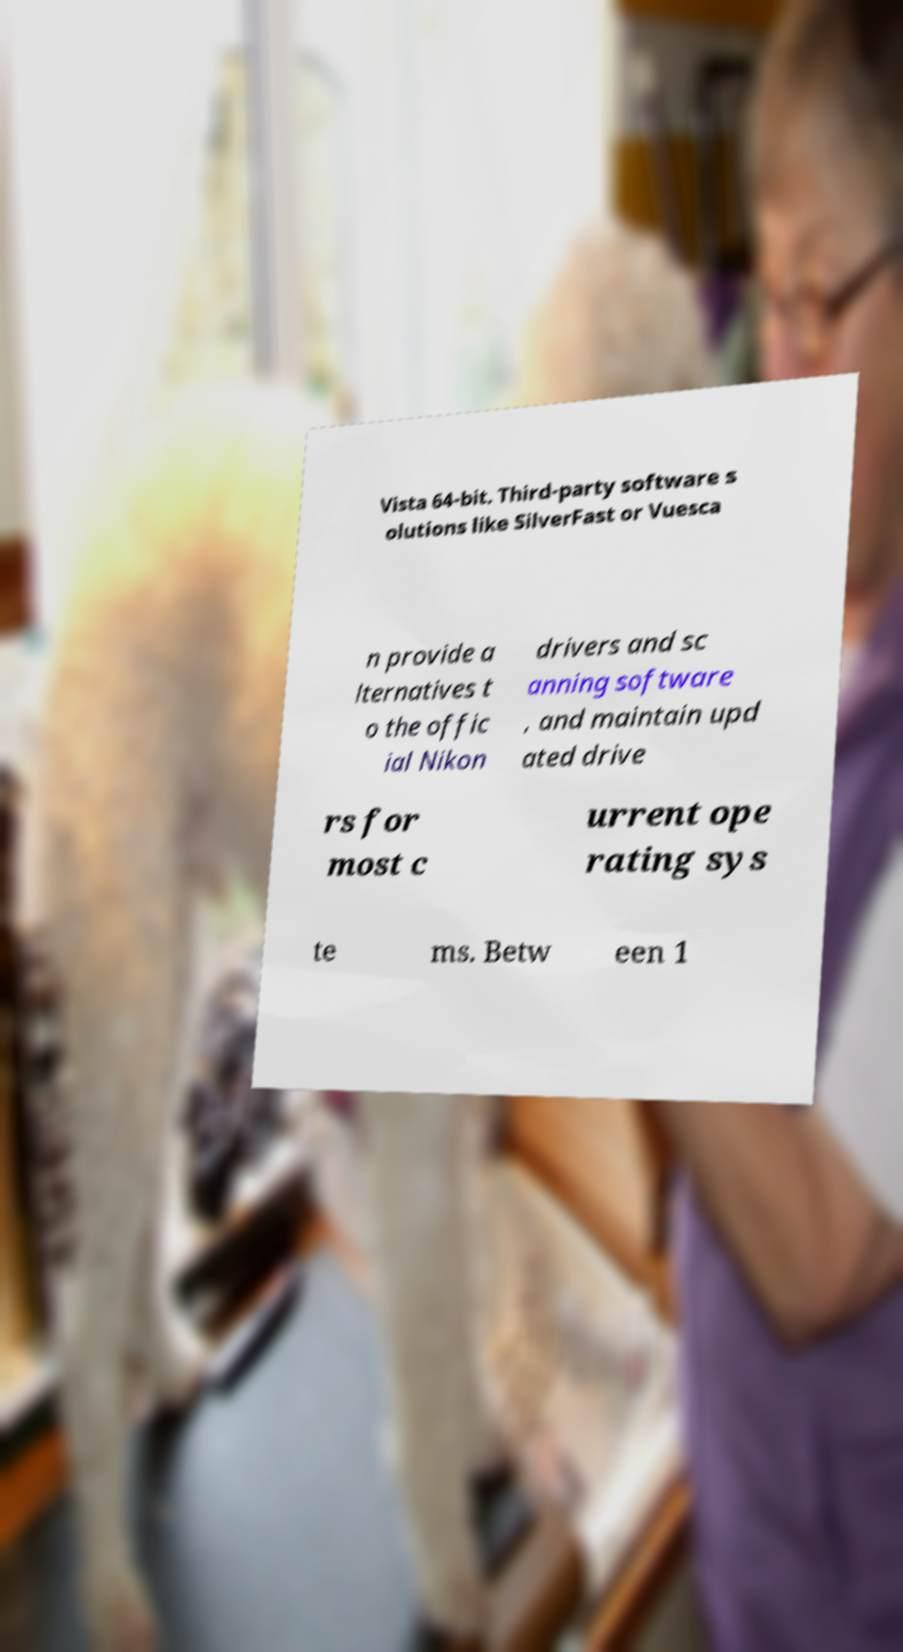What messages or text are displayed in this image? I need them in a readable, typed format. Vista 64-bit. Third-party software s olutions like SilverFast or Vuesca n provide a lternatives t o the offic ial Nikon drivers and sc anning software , and maintain upd ated drive rs for most c urrent ope rating sys te ms. Betw een 1 